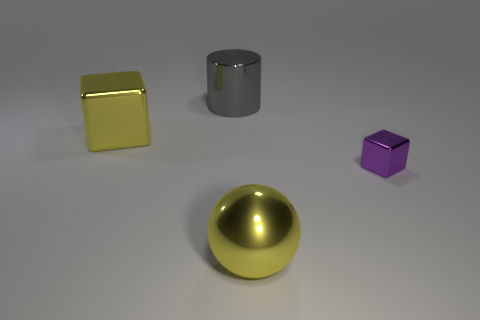Are there any large cyan metal objects that have the same shape as the gray thing?
Provide a succinct answer. No. What number of objects are big things to the left of the shiny cylinder or cylinders?
Give a very brief answer. 2. Are there more tiny yellow rubber blocks than big gray objects?
Your answer should be compact. No. Are there any metal balls that have the same size as the purple metallic cube?
Offer a terse response. No. What number of things are large metallic objects that are to the left of the yellow shiny sphere or tiny metallic objects behind the large metallic ball?
Make the answer very short. 3. What is the color of the shiny thing behind the big yellow shiny object behind the small shiny thing?
Provide a short and direct response. Gray. What is the color of the cylinder that is made of the same material as the yellow ball?
Make the answer very short. Gray. How many large blocks have the same color as the big metallic sphere?
Your response must be concise. 1. What number of things are big cyan matte blocks or tiny purple metal cubes?
Provide a short and direct response. 1. What is the shape of the gray thing that is the same size as the sphere?
Your response must be concise. Cylinder. 